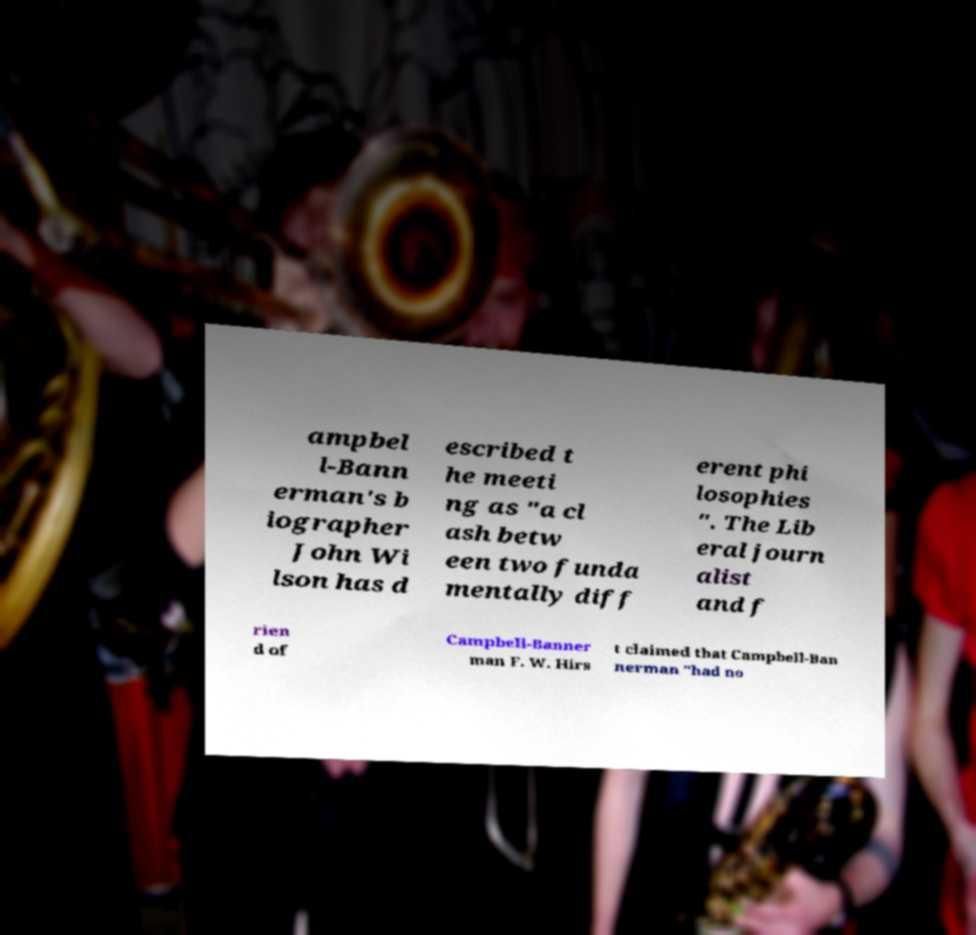Can you read and provide the text displayed in the image?This photo seems to have some interesting text. Can you extract and type it out for me? ampbel l-Bann erman's b iographer John Wi lson has d escribed t he meeti ng as "a cl ash betw een two funda mentally diff erent phi losophies ". The Lib eral journ alist and f rien d of Campbell-Banner man F. W. Hirs t claimed that Campbell-Ban nerman "had no 